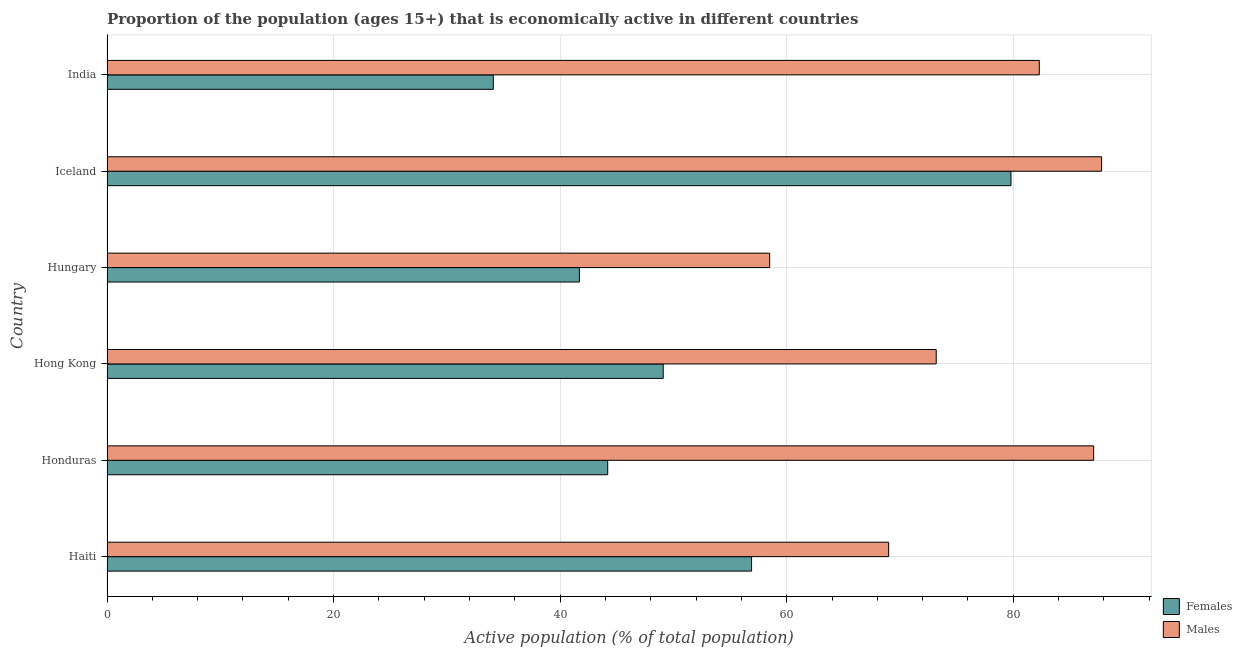How many groups of bars are there?
Your response must be concise. 6. Are the number of bars per tick equal to the number of legend labels?
Ensure brevity in your answer.  Yes. How many bars are there on the 4th tick from the bottom?
Offer a very short reply. 2. What is the label of the 4th group of bars from the top?
Give a very brief answer. Hong Kong. What is the percentage of economically active female population in Honduras?
Offer a very short reply. 44.2. Across all countries, what is the maximum percentage of economically active female population?
Give a very brief answer. 79.8. Across all countries, what is the minimum percentage of economically active male population?
Your response must be concise. 58.5. What is the total percentage of economically active male population in the graph?
Your response must be concise. 457.9. What is the difference between the percentage of economically active male population in Honduras and that in Iceland?
Your response must be concise. -0.7. What is the difference between the percentage of economically active male population in Hungary and the percentage of economically active female population in Honduras?
Provide a succinct answer. 14.3. What is the average percentage of economically active female population per country?
Your answer should be compact. 50.97. What is the difference between the percentage of economically active male population and percentage of economically active female population in Hungary?
Your answer should be very brief. 16.8. What is the ratio of the percentage of economically active female population in Haiti to that in Hungary?
Make the answer very short. 1.36. Is the percentage of economically active female population in Haiti less than that in Honduras?
Provide a succinct answer. No. What is the difference between the highest and the second highest percentage of economically active female population?
Keep it short and to the point. 22.9. What is the difference between the highest and the lowest percentage of economically active male population?
Your answer should be compact. 29.3. What does the 2nd bar from the top in India represents?
Give a very brief answer. Females. What does the 2nd bar from the bottom in Hungary represents?
Provide a short and direct response. Males. Are all the bars in the graph horizontal?
Your answer should be compact. Yes. Where does the legend appear in the graph?
Offer a very short reply. Bottom right. How are the legend labels stacked?
Provide a short and direct response. Vertical. What is the title of the graph?
Offer a very short reply. Proportion of the population (ages 15+) that is economically active in different countries. Does "Food" appear as one of the legend labels in the graph?
Ensure brevity in your answer.  No. What is the label or title of the X-axis?
Your answer should be very brief. Active population (% of total population). What is the label or title of the Y-axis?
Offer a very short reply. Country. What is the Active population (% of total population) of Females in Haiti?
Keep it short and to the point. 56.9. What is the Active population (% of total population) in Females in Honduras?
Provide a short and direct response. 44.2. What is the Active population (% of total population) of Males in Honduras?
Your answer should be very brief. 87.1. What is the Active population (% of total population) of Females in Hong Kong?
Offer a terse response. 49.1. What is the Active population (% of total population) in Males in Hong Kong?
Your response must be concise. 73.2. What is the Active population (% of total population) of Females in Hungary?
Offer a very short reply. 41.7. What is the Active population (% of total population) in Males in Hungary?
Offer a very short reply. 58.5. What is the Active population (% of total population) in Females in Iceland?
Your answer should be compact. 79.8. What is the Active population (% of total population) of Males in Iceland?
Make the answer very short. 87.8. What is the Active population (% of total population) of Females in India?
Offer a very short reply. 34.1. What is the Active population (% of total population) in Males in India?
Your answer should be very brief. 82.3. Across all countries, what is the maximum Active population (% of total population) of Females?
Ensure brevity in your answer.  79.8. Across all countries, what is the maximum Active population (% of total population) of Males?
Ensure brevity in your answer.  87.8. Across all countries, what is the minimum Active population (% of total population) of Females?
Your answer should be compact. 34.1. Across all countries, what is the minimum Active population (% of total population) of Males?
Keep it short and to the point. 58.5. What is the total Active population (% of total population) in Females in the graph?
Ensure brevity in your answer.  305.8. What is the total Active population (% of total population) of Males in the graph?
Your answer should be compact. 457.9. What is the difference between the Active population (% of total population) in Females in Haiti and that in Honduras?
Your answer should be very brief. 12.7. What is the difference between the Active population (% of total population) in Males in Haiti and that in Honduras?
Provide a short and direct response. -18.1. What is the difference between the Active population (% of total population) in Females in Haiti and that in Hungary?
Offer a terse response. 15.2. What is the difference between the Active population (% of total population) in Females in Haiti and that in Iceland?
Offer a very short reply. -22.9. What is the difference between the Active population (% of total population) of Males in Haiti and that in Iceland?
Provide a short and direct response. -18.8. What is the difference between the Active population (% of total population) in Females in Haiti and that in India?
Ensure brevity in your answer.  22.8. What is the difference between the Active population (% of total population) in Males in Haiti and that in India?
Offer a terse response. -13.3. What is the difference between the Active population (% of total population) in Males in Honduras and that in Hong Kong?
Offer a very short reply. 13.9. What is the difference between the Active population (% of total population) in Males in Honduras and that in Hungary?
Make the answer very short. 28.6. What is the difference between the Active population (% of total population) of Females in Honduras and that in Iceland?
Offer a terse response. -35.6. What is the difference between the Active population (% of total population) in Females in Honduras and that in India?
Make the answer very short. 10.1. What is the difference between the Active population (% of total population) in Females in Hong Kong and that in Iceland?
Make the answer very short. -30.7. What is the difference between the Active population (% of total population) of Males in Hong Kong and that in Iceland?
Provide a short and direct response. -14.6. What is the difference between the Active population (% of total population) of Females in Hong Kong and that in India?
Your answer should be very brief. 15. What is the difference between the Active population (% of total population) of Females in Hungary and that in Iceland?
Provide a short and direct response. -38.1. What is the difference between the Active population (% of total population) in Males in Hungary and that in Iceland?
Your answer should be compact. -29.3. What is the difference between the Active population (% of total population) of Males in Hungary and that in India?
Make the answer very short. -23.8. What is the difference between the Active population (% of total population) in Females in Iceland and that in India?
Ensure brevity in your answer.  45.7. What is the difference between the Active population (% of total population) in Females in Haiti and the Active population (% of total population) in Males in Honduras?
Offer a very short reply. -30.2. What is the difference between the Active population (% of total population) of Females in Haiti and the Active population (% of total population) of Males in Hong Kong?
Provide a short and direct response. -16.3. What is the difference between the Active population (% of total population) in Females in Haiti and the Active population (% of total population) in Males in Iceland?
Offer a terse response. -30.9. What is the difference between the Active population (% of total population) in Females in Haiti and the Active population (% of total population) in Males in India?
Offer a very short reply. -25.4. What is the difference between the Active population (% of total population) in Females in Honduras and the Active population (% of total population) in Males in Hungary?
Provide a short and direct response. -14.3. What is the difference between the Active population (% of total population) of Females in Honduras and the Active population (% of total population) of Males in Iceland?
Your response must be concise. -43.6. What is the difference between the Active population (% of total population) of Females in Honduras and the Active population (% of total population) of Males in India?
Provide a short and direct response. -38.1. What is the difference between the Active population (% of total population) of Females in Hong Kong and the Active population (% of total population) of Males in Iceland?
Make the answer very short. -38.7. What is the difference between the Active population (% of total population) in Females in Hong Kong and the Active population (% of total population) in Males in India?
Offer a very short reply. -33.2. What is the difference between the Active population (% of total population) of Females in Hungary and the Active population (% of total population) of Males in Iceland?
Keep it short and to the point. -46.1. What is the difference between the Active population (% of total population) of Females in Hungary and the Active population (% of total population) of Males in India?
Provide a succinct answer. -40.6. What is the difference between the Active population (% of total population) in Females in Iceland and the Active population (% of total population) in Males in India?
Keep it short and to the point. -2.5. What is the average Active population (% of total population) in Females per country?
Give a very brief answer. 50.97. What is the average Active population (% of total population) in Males per country?
Provide a succinct answer. 76.32. What is the difference between the Active population (% of total population) of Females and Active population (% of total population) of Males in Honduras?
Offer a terse response. -42.9. What is the difference between the Active population (% of total population) of Females and Active population (% of total population) of Males in Hong Kong?
Offer a very short reply. -24.1. What is the difference between the Active population (% of total population) of Females and Active population (% of total population) of Males in Hungary?
Your answer should be very brief. -16.8. What is the difference between the Active population (% of total population) in Females and Active population (% of total population) in Males in India?
Your response must be concise. -48.2. What is the ratio of the Active population (% of total population) of Females in Haiti to that in Honduras?
Your answer should be compact. 1.29. What is the ratio of the Active population (% of total population) of Males in Haiti to that in Honduras?
Give a very brief answer. 0.79. What is the ratio of the Active population (% of total population) in Females in Haiti to that in Hong Kong?
Provide a succinct answer. 1.16. What is the ratio of the Active population (% of total population) in Males in Haiti to that in Hong Kong?
Your response must be concise. 0.94. What is the ratio of the Active population (% of total population) in Females in Haiti to that in Hungary?
Make the answer very short. 1.36. What is the ratio of the Active population (% of total population) in Males in Haiti to that in Hungary?
Your answer should be very brief. 1.18. What is the ratio of the Active population (% of total population) of Females in Haiti to that in Iceland?
Ensure brevity in your answer.  0.71. What is the ratio of the Active population (% of total population) in Males in Haiti to that in Iceland?
Provide a succinct answer. 0.79. What is the ratio of the Active population (% of total population) of Females in Haiti to that in India?
Your answer should be very brief. 1.67. What is the ratio of the Active population (% of total population) of Males in Haiti to that in India?
Offer a terse response. 0.84. What is the ratio of the Active population (% of total population) of Females in Honduras to that in Hong Kong?
Offer a terse response. 0.9. What is the ratio of the Active population (% of total population) of Males in Honduras to that in Hong Kong?
Make the answer very short. 1.19. What is the ratio of the Active population (% of total population) in Females in Honduras to that in Hungary?
Offer a terse response. 1.06. What is the ratio of the Active population (% of total population) in Males in Honduras to that in Hungary?
Keep it short and to the point. 1.49. What is the ratio of the Active population (% of total population) of Females in Honduras to that in Iceland?
Ensure brevity in your answer.  0.55. What is the ratio of the Active population (% of total population) of Males in Honduras to that in Iceland?
Offer a very short reply. 0.99. What is the ratio of the Active population (% of total population) of Females in Honduras to that in India?
Your response must be concise. 1.3. What is the ratio of the Active population (% of total population) in Males in Honduras to that in India?
Your answer should be very brief. 1.06. What is the ratio of the Active population (% of total population) in Females in Hong Kong to that in Hungary?
Provide a short and direct response. 1.18. What is the ratio of the Active population (% of total population) of Males in Hong Kong to that in Hungary?
Ensure brevity in your answer.  1.25. What is the ratio of the Active population (% of total population) in Females in Hong Kong to that in Iceland?
Your answer should be compact. 0.62. What is the ratio of the Active population (% of total population) in Males in Hong Kong to that in Iceland?
Ensure brevity in your answer.  0.83. What is the ratio of the Active population (% of total population) in Females in Hong Kong to that in India?
Provide a short and direct response. 1.44. What is the ratio of the Active population (% of total population) of Males in Hong Kong to that in India?
Offer a very short reply. 0.89. What is the ratio of the Active population (% of total population) of Females in Hungary to that in Iceland?
Your response must be concise. 0.52. What is the ratio of the Active population (% of total population) in Males in Hungary to that in Iceland?
Offer a terse response. 0.67. What is the ratio of the Active population (% of total population) of Females in Hungary to that in India?
Offer a very short reply. 1.22. What is the ratio of the Active population (% of total population) in Males in Hungary to that in India?
Offer a terse response. 0.71. What is the ratio of the Active population (% of total population) in Females in Iceland to that in India?
Make the answer very short. 2.34. What is the ratio of the Active population (% of total population) of Males in Iceland to that in India?
Your answer should be very brief. 1.07. What is the difference between the highest and the second highest Active population (% of total population) of Females?
Offer a terse response. 22.9. What is the difference between the highest and the lowest Active population (% of total population) in Females?
Your response must be concise. 45.7. What is the difference between the highest and the lowest Active population (% of total population) in Males?
Your answer should be very brief. 29.3. 